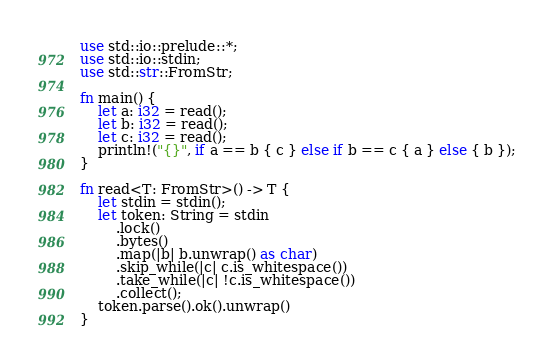Convert code to text. <code><loc_0><loc_0><loc_500><loc_500><_Rust_>use std::io::prelude::*;
use std::io::stdin;
use std::str::FromStr;

fn main() {
    let a: i32 = read();
    let b: i32 = read();
    let c: i32 = read();
    println!("{}", if a == b { c } else if b == c { a } else { b });
}

fn read<T: FromStr>() -> T {
    let stdin = stdin();
    let token: String = stdin
        .lock()
        .bytes()
        .map(|b| b.unwrap() as char)
        .skip_while(|c| c.is_whitespace())
        .take_while(|c| !c.is_whitespace())
        .collect();
    token.parse().ok().unwrap()
}
</code> 